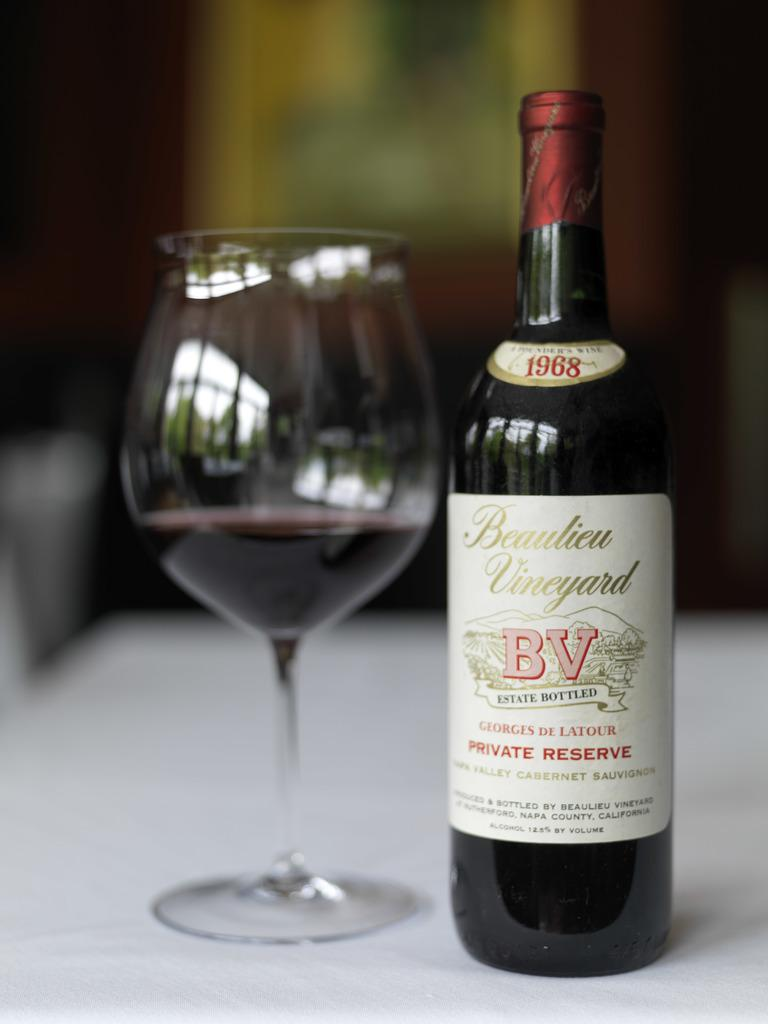What is on the table in the image? There is a glass and a wine bottle on the table in the image. What can be seen in the background of the image? There is a wall in the background of the image. What is hanging on the wall in the background of the image? There is a photo frame on the wall in the background of the image. What type of scarf is being used to comb the hair of the person in the image? There is no person or scarf present in the image; it only features a glass, a wine bottle, a wall, and a photo frame. 